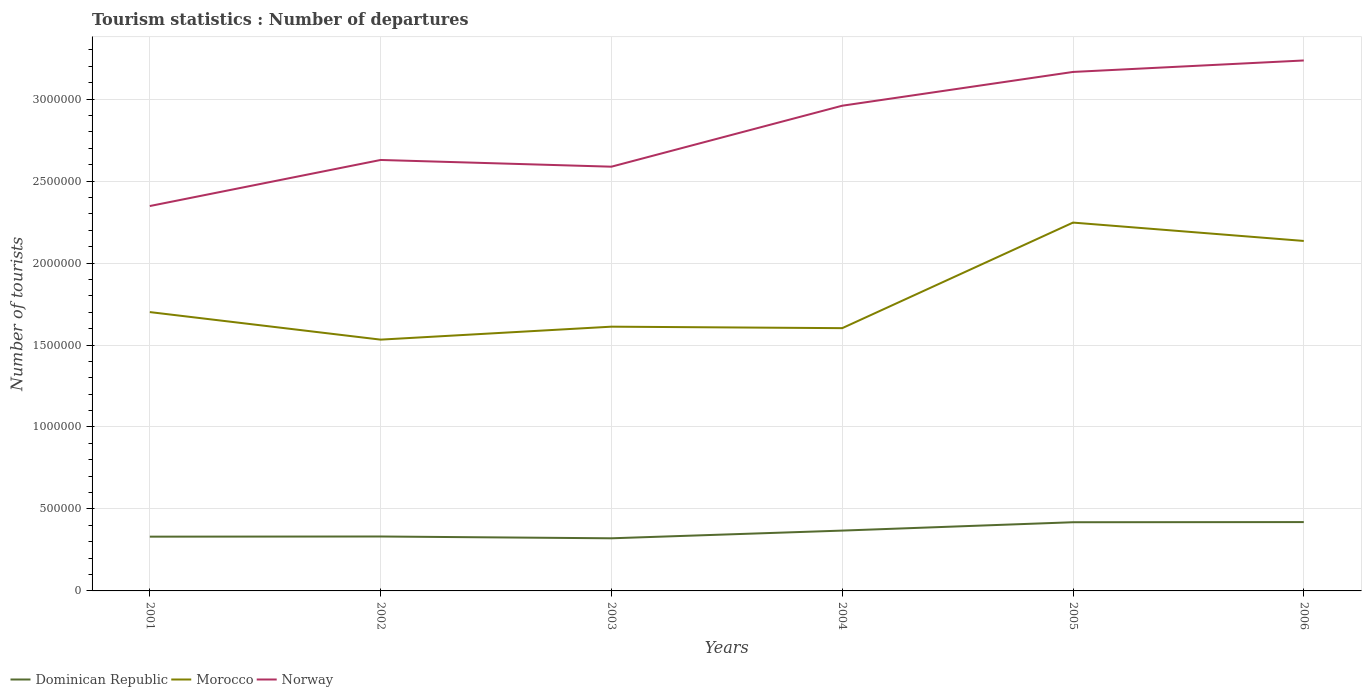How many different coloured lines are there?
Give a very brief answer. 3. Across all years, what is the maximum number of tourist departures in Morocco?
Make the answer very short. 1.53e+06. In which year was the number of tourist departures in Morocco maximum?
Ensure brevity in your answer.  2002. What is the total number of tourist departures in Dominican Republic in the graph?
Make the answer very short. -8.80e+04. What is the difference between the highest and the second highest number of tourist departures in Dominican Republic?
Give a very brief answer. 9.90e+04. How many lines are there?
Offer a very short reply. 3. Does the graph contain any zero values?
Provide a succinct answer. No. Where does the legend appear in the graph?
Provide a succinct answer. Bottom left. How many legend labels are there?
Give a very brief answer. 3. What is the title of the graph?
Give a very brief answer. Tourism statistics : Number of departures. What is the label or title of the X-axis?
Keep it short and to the point. Years. What is the label or title of the Y-axis?
Your answer should be very brief. Number of tourists. What is the Number of tourists in Dominican Republic in 2001?
Your response must be concise. 3.31e+05. What is the Number of tourists of Morocco in 2001?
Keep it short and to the point. 1.70e+06. What is the Number of tourists of Norway in 2001?
Ensure brevity in your answer.  2.35e+06. What is the Number of tourists of Dominican Republic in 2002?
Offer a terse response. 3.32e+05. What is the Number of tourists of Morocco in 2002?
Provide a succinct answer. 1.53e+06. What is the Number of tourists of Norway in 2002?
Your answer should be very brief. 2.63e+06. What is the Number of tourists of Dominican Republic in 2003?
Give a very brief answer. 3.21e+05. What is the Number of tourists of Morocco in 2003?
Your response must be concise. 1.61e+06. What is the Number of tourists in Norway in 2003?
Make the answer very short. 2.59e+06. What is the Number of tourists in Dominican Republic in 2004?
Offer a terse response. 3.68e+05. What is the Number of tourists in Morocco in 2004?
Your answer should be compact. 1.60e+06. What is the Number of tourists in Norway in 2004?
Offer a terse response. 2.96e+06. What is the Number of tourists of Dominican Republic in 2005?
Make the answer very short. 4.19e+05. What is the Number of tourists of Morocco in 2005?
Your response must be concise. 2.25e+06. What is the Number of tourists of Norway in 2005?
Keep it short and to the point. 3.17e+06. What is the Number of tourists of Morocco in 2006?
Ensure brevity in your answer.  2.14e+06. What is the Number of tourists of Norway in 2006?
Offer a very short reply. 3.24e+06. Across all years, what is the maximum Number of tourists of Dominican Republic?
Provide a succinct answer. 4.20e+05. Across all years, what is the maximum Number of tourists in Morocco?
Ensure brevity in your answer.  2.25e+06. Across all years, what is the maximum Number of tourists in Norway?
Make the answer very short. 3.24e+06. Across all years, what is the minimum Number of tourists in Dominican Republic?
Your answer should be very brief. 3.21e+05. Across all years, what is the minimum Number of tourists of Morocco?
Offer a terse response. 1.53e+06. Across all years, what is the minimum Number of tourists of Norway?
Provide a succinct answer. 2.35e+06. What is the total Number of tourists of Dominican Republic in the graph?
Your response must be concise. 2.19e+06. What is the total Number of tourists of Morocco in the graph?
Make the answer very short. 1.08e+07. What is the total Number of tourists of Norway in the graph?
Your response must be concise. 1.69e+07. What is the difference between the Number of tourists of Dominican Republic in 2001 and that in 2002?
Your answer should be compact. -1000. What is the difference between the Number of tourists of Morocco in 2001 and that in 2002?
Provide a short and direct response. 1.68e+05. What is the difference between the Number of tourists of Norway in 2001 and that in 2002?
Ensure brevity in your answer.  -2.81e+05. What is the difference between the Number of tourists in Dominican Republic in 2001 and that in 2003?
Offer a terse response. 10000. What is the difference between the Number of tourists in Morocco in 2001 and that in 2003?
Your response must be concise. 8.90e+04. What is the difference between the Number of tourists in Norway in 2001 and that in 2003?
Make the answer very short. -2.40e+05. What is the difference between the Number of tourists in Dominican Republic in 2001 and that in 2004?
Offer a very short reply. -3.70e+04. What is the difference between the Number of tourists in Morocco in 2001 and that in 2004?
Offer a terse response. 9.80e+04. What is the difference between the Number of tourists in Norway in 2001 and that in 2004?
Ensure brevity in your answer.  -6.12e+05. What is the difference between the Number of tourists of Dominican Republic in 2001 and that in 2005?
Your response must be concise. -8.80e+04. What is the difference between the Number of tourists in Morocco in 2001 and that in 2005?
Ensure brevity in your answer.  -5.46e+05. What is the difference between the Number of tourists of Norway in 2001 and that in 2005?
Provide a short and direct response. -8.18e+05. What is the difference between the Number of tourists of Dominican Republic in 2001 and that in 2006?
Your response must be concise. -8.90e+04. What is the difference between the Number of tourists of Morocco in 2001 and that in 2006?
Your answer should be compact. -4.34e+05. What is the difference between the Number of tourists of Norway in 2001 and that in 2006?
Provide a succinct answer. -8.88e+05. What is the difference between the Number of tourists of Dominican Republic in 2002 and that in 2003?
Ensure brevity in your answer.  1.10e+04. What is the difference between the Number of tourists in Morocco in 2002 and that in 2003?
Offer a very short reply. -7.90e+04. What is the difference between the Number of tourists in Norway in 2002 and that in 2003?
Make the answer very short. 4.10e+04. What is the difference between the Number of tourists of Dominican Republic in 2002 and that in 2004?
Offer a very short reply. -3.60e+04. What is the difference between the Number of tourists of Morocco in 2002 and that in 2004?
Your answer should be very brief. -7.00e+04. What is the difference between the Number of tourists in Norway in 2002 and that in 2004?
Your answer should be compact. -3.31e+05. What is the difference between the Number of tourists of Dominican Republic in 2002 and that in 2005?
Keep it short and to the point. -8.70e+04. What is the difference between the Number of tourists in Morocco in 2002 and that in 2005?
Provide a short and direct response. -7.14e+05. What is the difference between the Number of tourists of Norway in 2002 and that in 2005?
Make the answer very short. -5.37e+05. What is the difference between the Number of tourists in Dominican Republic in 2002 and that in 2006?
Your answer should be very brief. -8.80e+04. What is the difference between the Number of tourists in Morocco in 2002 and that in 2006?
Your answer should be compact. -6.02e+05. What is the difference between the Number of tourists in Norway in 2002 and that in 2006?
Provide a succinct answer. -6.07e+05. What is the difference between the Number of tourists in Dominican Republic in 2003 and that in 2004?
Give a very brief answer. -4.70e+04. What is the difference between the Number of tourists in Morocco in 2003 and that in 2004?
Provide a succinct answer. 9000. What is the difference between the Number of tourists in Norway in 2003 and that in 2004?
Make the answer very short. -3.72e+05. What is the difference between the Number of tourists in Dominican Republic in 2003 and that in 2005?
Provide a short and direct response. -9.80e+04. What is the difference between the Number of tourists of Morocco in 2003 and that in 2005?
Provide a short and direct response. -6.35e+05. What is the difference between the Number of tourists in Norway in 2003 and that in 2005?
Offer a very short reply. -5.78e+05. What is the difference between the Number of tourists of Dominican Republic in 2003 and that in 2006?
Ensure brevity in your answer.  -9.90e+04. What is the difference between the Number of tourists in Morocco in 2003 and that in 2006?
Make the answer very short. -5.23e+05. What is the difference between the Number of tourists of Norway in 2003 and that in 2006?
Give a very brief answer. -6.48e+05. What is the difference between the Number of tourists of Dominican Republic in 2004 and that in 2005?
Offer a terse response. -5.10e+04. What is the difference between the Number of tourists in Morocco in 2004 and that in 2005?
Offer a terse response. -6.44e+05. What is the difference between the Number of tourists of Norway in 2004 and that in 2005?
Offer a terse response. -2.06e+05. What is the difference between the Number of tourists of Dominican Republic in 2004 and that in 2006?
Make the answer very short. -5.20e+04. What is the difference between the Number of tourists in Morocco in 2004 and that in 2006?
Provide a succinct answer. -5.32e+05. What is the difference between the Number of tourists in Norway in 2004 and that in 2006?
Provide a short and direct response. -2.76e+05. What is the difference between the Number of tourists in Dominican Republic in 2005 and that in 2006?
Offer a very short reply. -1000. What is the difference between the Number of tourists of Morocco in 2005 and that in 2006?
Your answer should be compact. 1.12e+05. What is the difference between the Number of tourists in Dominican Republic in 2001 and the Number of tourists in Morocco in 2002?
Ensure brevity in your answer.  -1.20e+06. What is the difference between the Number of tourists of Dominican Republic in 2001 and the Number of tourists of Norway in 2002?
Offer a very short reply. -2.30e+06. What is the difference between the Number of tourists of Morocco in 2001 and the Number of tourists of Norway in 2002?
Offer a terse response. -9.28e+05. What is the difference between the Number of tourists in Dominican Republic in 2001 and the Number of tourists in Morocco in 2003?
Keep it short and to the point. -1.28e+06. What is the difference between the Number of tourists of Dominican Republic in 2001 and the Number of tourists of Norway in 2003?
Offer a terse response. -2.26e+06. What is the difference between the Number of tourists in Morocco in 2001 and the Number of tourists in Norway in 2003?
Your answer should be very brief. -8.87e+05. What is the difference between the Number of tourists in Dominican Republic in 2001 and the Number of tourists in Morocco in 2004?
Keep it short and to the point. -1.27e+06. What is the difference between the Number of tourists in Dominican Republic in 2001 and the Number of tourists in Norway in 2004?
Offer a very short reply. -2.63e+06. What is the difference between the Number of tourists in Morocco in 2001 and the Number of tourists in Norway in 2004?
Offer a terse response. -1.26e+06. What is the difference between the Number of tourists in Dominican Republic in 2001 and the Number of tourists in Morocco in 2005?
Your response must be concise. -1.92e+06. What is the difference between the Number of tourists of Dominican Republic in 2001 and the Number of tourists of Norway in 2005?
Your answer should be very brief. -2.84e+06. What is the difference between the Number of tourists in Morocco in 2001 and the Number of tourists in Norway in 2005?
Offer a terse response. -1.46e+06. What is the difference between the Number of tourists of Dominican Republic in 2001 and the Number of tourists of Morocco in 2006?
Your response must be concise. -1.80e+06. What is the difference between the Number of tourists in Dominican Republic in 2001 and the Number of tourists in Norway in 2006?
Your answer should be compact. -2.90e+06. What is the difference between the Number of tourists of Morocco in 2001 and the Number of tourists of Norway in 2006?
Your response must be concise. -1.54e+06. What is the difference between the Number of tourists in Dominican Republic in 2002 and the Number of tourists in Morocco in 2003?
Your answer should be compact. -1.28e+06. What is the difference between the Number of tourists of Dominican Republic in 2002 and the Number of tourists of Norway in 2003?
Offer a terse response. -2.26e+06. What is the difference between the Number of tourists of Morocco in 2002 and the Number of tourists of Norway in 2003?
Ensure brevity in your answer.  -1.06e+06. What is the difference between the Number of tourists of Dominican Republic in 2002 and the Number of tourists of Morocco in 2004?
Provide a succinct answer. -1.27e+06. What is the difference between the Number of tourists of Dominican Republic in 2002 and the Number of tourists of Norway in 2004?
Give a very brief answer. -2.63e+06. What is the difference between the Number of tourists in Morocco in 2002 and the Number of tourists in Norway in 2004?
Keep it short and to the point. -1.43e+06. What is the difference between the Number of tourists of Dominican Republic in 2002 and the Number of tourists of Morocco in 2005?
Provide a succinct answer. -1.92e+06. What is the difference between the Number of tourists in Dominican Republic in 2002 and the Number of tourists in Norway in 2005?
Keep it short and to the point. -2.83e+06. What is the difference between the Number of tourists in Morocco in 2002 and the Number of tourists in Norway in 2005?
Your answer should be compact. -1.63e+06. What is the difference between the Number of tourists in Dominican Republic in 2002 and the Number of tourists in Morocco in 2006?
Keep it short and to the point. -1.80e+06. What is the difference between the Number of tourists in Dominican Republic in 2002 and the Number of tourists in Norway in 2006?
Offer a very short reply. -2.90e+06. What is the difference between the Number of tourists in Morocco in 2002 and the Number of tourists in Norway in 2006?
Your answer should be very brief. -1.70e+06. What is the difference between the Number of tourists in Dominican Republic in 2003 and the Number of tourists in Morocco in 2004?
Offer a very short reply. -1.28e+06. What is the difference between the Number of tourists of Dominican Republic in 2003 and the Number of tourists of Norway in 2004?
Offer a terse response. -2.64e+06. What is the difference between the Number of tourists in Morocco in 2003 and the Number of tourists in Norway in 2004?
Provide a short and direct response. -1.35e+06. What is the difference between the Number of tourists in Dominican Republic in 2003 and the Number of tourists in Morocco in 2005?
Provide a succinct answer. -1.93e+06. What is the difference between the Number of tourists in Dominican Republic in 2003 and the Number of tourists in Norway in 2005?
Give a very brief answer. -2.84e+06. What is the difference between the Number of tourists of Morocco in 2003 and the Number of tourists of Norway in 2005?
Offer a very short reply. -1.55e+06. What is the difference between the Number of tourists of Dominican Republic in 2003 and the Number of tourists of Morocco in 2006?
Your answer should be compact. -1.81e+06. What is the difference between the Number of tourists of Dominican Republic in 2003 and the Number of tourists of Norway in 2006?
Make the answer very short. -2.92e+06. What is the difference between the Number of tourists in Morocco in 2003 and the Number of tourists in Norway in 2006?
Ensure brevity in your answer.  -1.62e+06. What is the difference between the Number of tourists of Dominican Republic in 2004 and the Number of tourists of Morocco in 2005?
Your response must be concise. -1.88e+06. What is the difference between the Number of tourists in Dominican Republic in 2004 and the Number of tourists in Norway in 2005?
Your answer should be compact. -2.80e+06. What is the difference between the Number of tourists of Morocco in 2004 and the Number of tourists of Norway in 2005?
Make the answer very short. -1.56e+06. What is the difference between the Number of tourists in Dominican Republic in 2004 and the Number of tourists in Morocco in 2006?
Your response must be concise. -1.77e+06. What is the difference between the Number of tourists of Dominican Republic in 2004 and the Number of tourists of Norway in 2006?
Make the answer very short. -2.87e+06. What is the difference between the Number of tourists in Morocco in 2004 and the Number of tourists in Norway in 2006?
Ensure brevity in your answer.  -1.63e+06. What is the difference between the Number of tourists of Dominican Republic in 2005 and the Number of tourists of Morocco in 2006?
Your answer should be compact. -1.72e+06. What is the difference between the Number of tourists in Dominican Republic in 2005 and the Number of tourists in Norway in 2006?
Your response must be concise. -2.82e+06. What is the difference between the Number of tourists in Morocco in 2005 and the Number of tourists in Norway in 2006?
Provide a short and direct response. -9.89e+05. What is the average Number of tourists in Dominican Republic per year?
Your response must be concise. 3.65e+05. What is the average Number of tourists in Morocco per year?
Give a very brief answer. 1.81e+06. What is the average Number of tourists of Norway per year?
Make the answer very short. 2.82e+06. In the year 2001, what is the difference between the Number of tourists in Dominican Republic and Number of tourists in Morocco?
Your response must be concise. -1.37e+06. In the year 2001, what is the difference between the Number of tourists in Dominican Republic and Number of tourists in Norway?
Ensure brevity in your answer.  -2.02e+06. In the year 2001, what is the difference between the Number of tourists of Morocco and Number of tourists of Norway?
Keep it short and to the point. -6.47e+05. In the year 2002, what is the difference between the Number of tourists in Dominican Republic and Number of tourists in Morocco?
Make the answer very short. -1.20e+06. In the year 2002, what is the difference between the Number of tourists of Dominican Republic and Number of tourists of Norway?
Your answer should be compact. -2.30e+06. In the year 2002, what is the difference between the Number of tourists of Morocco and Number of tourists of Norway?
Your answer should be compact. -1.10e+06. In the year 2003, what is the difference between the Number of tourists of Dominican Republic and Number of tourists of Morocco?
Keep it short and to the point. -1.29e+06. In the year 2003, what is the difference between the Number of tourists in Dominican Republic and Number of tourists in Norway?
Give a very brief answer. -2.27e+06. In the year 2003, what is the difference between the Number of tourists in Morocco and Number of tourists in Norway?
Your response must be concise. -9.76e+05. In the year 2004, what is the difference between the Number of tourists of Dominican Republic and Number of tourists of Morocco?
Your answer should be compact. -1.24e+06. In the year 2004, what is the difference between the Number of tourists in Dominican Republic and Number of tourists in Norway?
Keep it short and to the point. -2.59e+06. In the year 2004, what is the difference between the Number of tourists of Morocco and Number of tourists of Norway?
Your answer should be very brief. -1.36e+06. In the year 2005, what is the difference between the Number of tourists in Dominican Republic and Number of tourists in Morocco?
Make the answer very short. -1.83e+06. In the year 2005, what is the difference between the Number of tourists in Dominican Republic and Number of tourists in Norway?
Your response must be concise. -2.75e+06. In the year 2005, what is the difference between the Number of tourists of Morocco and Number of tourists of Norway?
Provide a short and direct response. -9.19e+05. In the year 2006, what is the difference between the Number of tourists in Dominican Republic and Number of tourists in Morocco?
Your answer should be very brief. -1.72e+06. In the year 2006, what is the difference between the Number of tourists of Dominican Republic and Number of tourists of Norway?
Offer a terse response. -2.82e+06. In the year 2006, what is the difference between the Number of tourists in Morocco and Number of tourists in Norway?
Provide a succinct answer. -1.10e+06. What is the ratio of the Number of tourists of Dominican Republic in 2001 to that in 2002?
Provide a short and direct response. 1. What is the ratio of the Number of tourists of Morocco in 2001 to that in 2002?
Your answer should be compact. 1.11. What is the ratio of the Number of tourists of Norway in 2001 to that in 2002?
Make the answer very short. 0.89. What is the ratio of the Number of tourists in Dominican Republic in 2001 to that in 2003?
Provide a succinct answer. 1.03. What is the ratio of the Number of tourists of Morocco in 2001 to that in 2003?
Provide a succinct answer. 1.06. What is the ratio of the Number of tourists in Norway in 2001 to that in 2003?
Provide a short and direct response. 0.91. What is the ratio of the Number of tourists of Dominican Republic in 2001 to that in 2004?
Offer a terse response. 0.9. What is the ratio of the Number of tourists in Morocco in 2001 to that in 2004?
Your answer should be compact. 1.06. What is the ratio of the Number of tourists of Norway in 2001 to that in 2004?
Make the answer very short. 0.79. What is the ratio of the Number of tourists in Dominican Republic in 2001 to that in 2005?
Offer a terse response. 0.79. What is the ratio of the Number of tourists in Morocco in 2001 to that in 2005?
Your response must be concise. 0.76. What is the ratio of the Number of tourists in Norway in 2001 to that in 2005?
Provide a succinct answer. 0.74. What is the ratio of the Number of tourists in Dominican Republic in 2001 to that in 2006?
Your response must be concise. 0.79. What is the ratio of the Number of tourists of Morocco in 2001 to that in 2006?
Give a very brief answer. 0.8. What is the ratio of the Number of tourists in Norway in 2001 to that in 2006?
Ensure brevity in your answer.  0.73. What is the ratio of the Number of tourists in Dominican Republic in 2002 to that in 2003?
Provide a succinct answer. 1.03. What is the ratio of the Number of tourists in Morocco in 2002 to that in 2003?
Ensure brevity in your answer.  0.95. What is the ratio of the Number of tourists in Norway in 2002 to that in 2003?
Keep it short and to the point. 1.02. What is the ratio of the Number of tourists of Dominican Republic in 2002 to that in 2004?
Keep it short and to the point. 0.9. What is the ratio of the Number of tourists of Morocco in 2002 to that in 2004?
Provide a short and direct response. 0.96. What is the ratio of the Number of tourists in Norway in 2002 to that in 2004?
Give a very brief answer. 0.89. What is the ratio of the Number of tourists of Dominican Republic in 2002 to that in 2005?
Ensure brevity in your answer.  0.79. What is the ratio of the Number of tourists of Morocco in 2002 to that in 2005?
Offer a very short reply. 0.68. What is the ratio of the Number of tourists of Norway in 2002 to that in 2005?
Your answer should be compact. 0.83. What is the ratio of the Number of tourists in Dominican Republic in 2002 to that in 2006?
Provide a succinct answer. 0.79. What is the ratio of the Number of tourists of Morocco in 2002 to that in 2006?
Keep it short and to the point. 0.72. What is the ratio of the Number of tourists in Norway in 2002 to that in 2006?
Provide a succinct answer. 0.81. What is the ratio of the Number of tourists of Dominican Republic in 2003 to that in 2004?
Provide a succinct answer. 0.87. What is the ratio of the Number of tourists in Morocco in 2003 to that in 2004?
Your answer should be compact. 1.01. What is the ratio of the Number of tourists in Norway in 2003 to that in 2004?
Make the answer very short. 0.87. What is the ratio of the Number of tourists in Dominican Republic in 2003 to that in 2005?
Provide a succinct answer. 0.77. What is the ratio of the Number of tourists of Morocco in 2003 to that in 2005?
Your answer should be very brief. 0.72. What is the ratio of the Number of tourists in Norway in 2003 to that in 2005?
Ensure brevity in your answer.  0.82. What is the ratio of the Number of tourists of Dominican Republic in 2003 to that in 2006?
Your answer should be compact. 0.76. What is the ratio of the Number of tourists in Morocco in 2003 to that in 2006?
Your answer should be very brief. 0.76. What is the ratio of the Number of tourists in Norway in 2003 to that in 2006?
Offer a terse response. 0.8. What is the ratio of the Number of tourists of Dominican Republic in 2004 to that in 2005?
Give a very brief answer. 0.88. What is the ratio of the Number of tourists of Morocco in 2004 to that in 2005?
Offer a terse response. 0.71. What is the ratio of the Number of tourists of Norway in 2004 to that in 2005?
Give a very brief answer. 0.93. What is the ratio of the Number of tourists in Dominican Republic in 2004 to that in 2006?
Give a very brief answer. 0.88. What is the ratio of the Number of tourists of Morocco in 2004 to that in 2006?
Keep it short and to the point. 0.75. What is the ratio of the Number of tourists of Norway in 2004 to that in 2006?
Keep it short and to the point. 0.91. What is the ratio of the Number of tourists in Morocco in 2005 to that in 2006?
Provide a succinct answer. 1.05. What is the ratio of the Number of tourists of Norway in 2005 to that in 2006?
Keep it short and to the point. 0.98. What is the difference between the highest and the second highest Number of tourists in Morocco?
Give a very brief answer. 1.12e+05. What is the difference between the highest and the second highest Number of tourists in Norway?
Your answer should be very brief. 7.00e+04. What is the difference between the highest and the lowest Number of tourists of Dominican Republic?
Provide a short and direct response. 9.90e+04. What is the difference between the highest and the lowest Number of tourists in Morocco?
Your answer should be compact. 7.14e+05. What is the difference between the highest and the lowest Number of tourists of Norway?
Provide a succinct answer. 8.88e+05. 